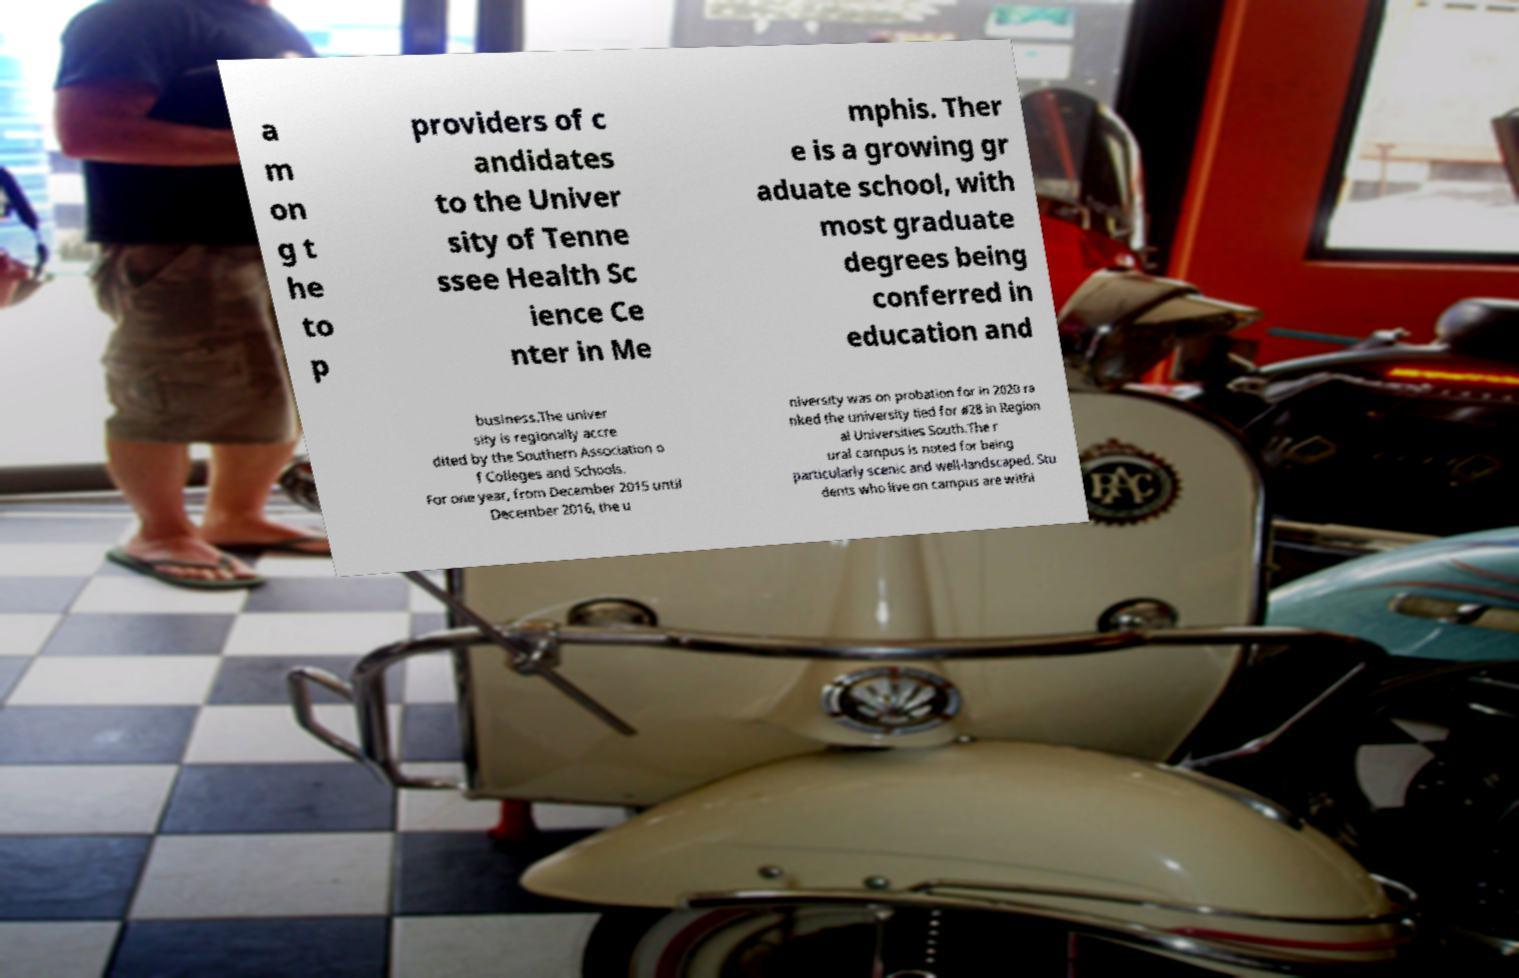Please read and relay the text visible in this image. What does it say? a m on g t he to p providers of c andidates to the Univer sity of Tenne ssee Health Sc ience Ce nter in Me mphis. Ther e is a growing gr aduate school, with most graduate degrees being conferred in education and business.The univer sity is regionally accre dited by the Southern Association o f Colleges and Schools. For one year, from December 2015 until December 2016, the u niversity was on probation for in 2020 ra nked the university tied for #28 in Region al Universities South.The r ural campus is noted for being particularly scenic and well-landscaped. Stu dents who live on campus are withi 